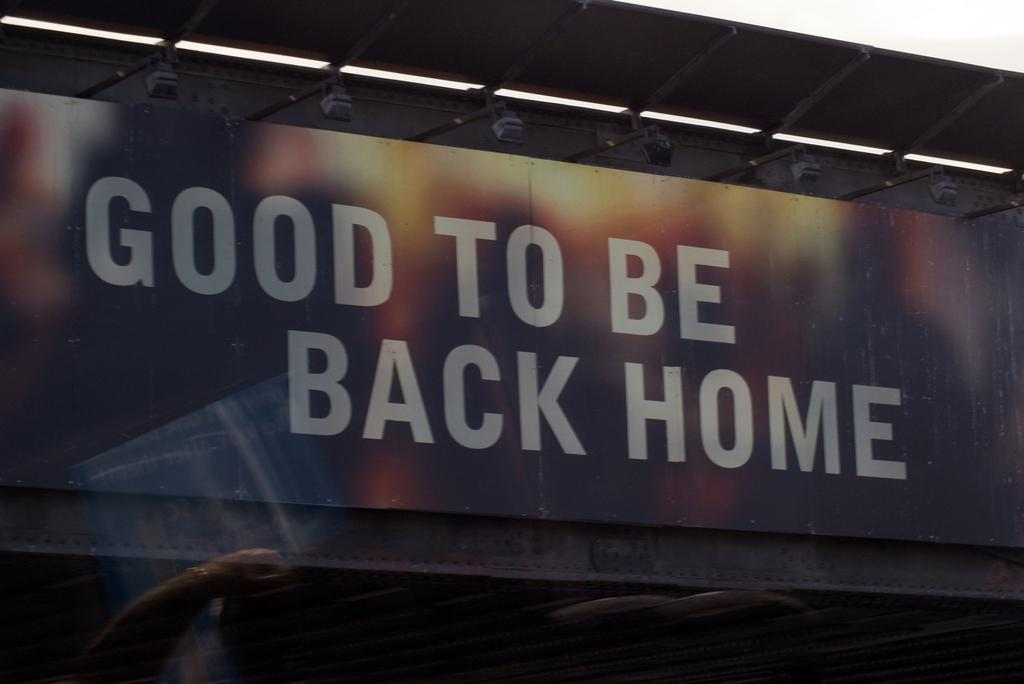<image>
Summarize the visual content of the image. An outdoor sign which reads "Good to be back home." 